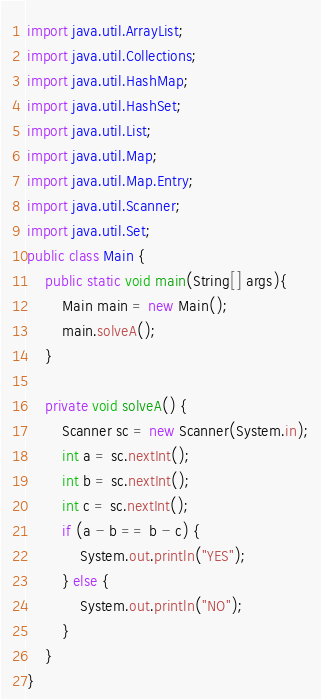<code> <loc_0><loc_0><loc_500><loc_500><_Java_>import java.util.ArrayList;
import java.util.Collections;
import java.util.HashMap;
import java.util.HashSet;
import java.util.List;
import java.util.Map;
import java.util.Map.Entry;
import java.util.Scanner;
import java.util.Set;
public class Main {
	public static void main(String[] args){
		Main main = new Main();
		main.solveA();
	}

	private void solveA() {
		Scanner sc = new Scanner(System.in);
		int a = sc.nextInt();
		int b = sc.nextInt();
		int c = sc.nextInt();
		if (a - b == b - c) {
			System.out.println("YES");
		} else {
			System.out.println("NO");
		}
	}
}</code> 